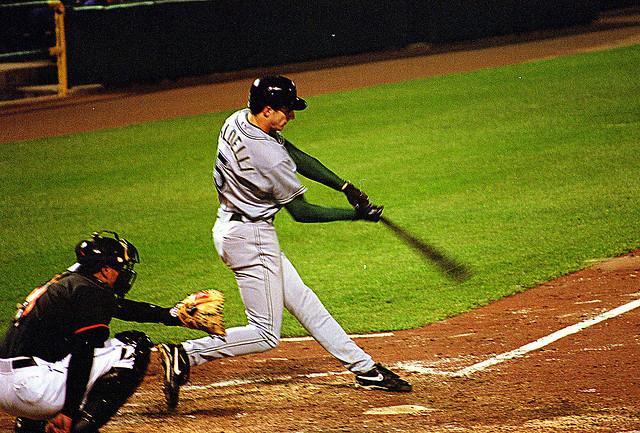Why is the baseball bat blurry?
Quick response, please. Yes. What is the person squatting behind the batter doing?
Short answer required. Catching. What color shirt is the catcher wearing?
Quick response, please. Black. 